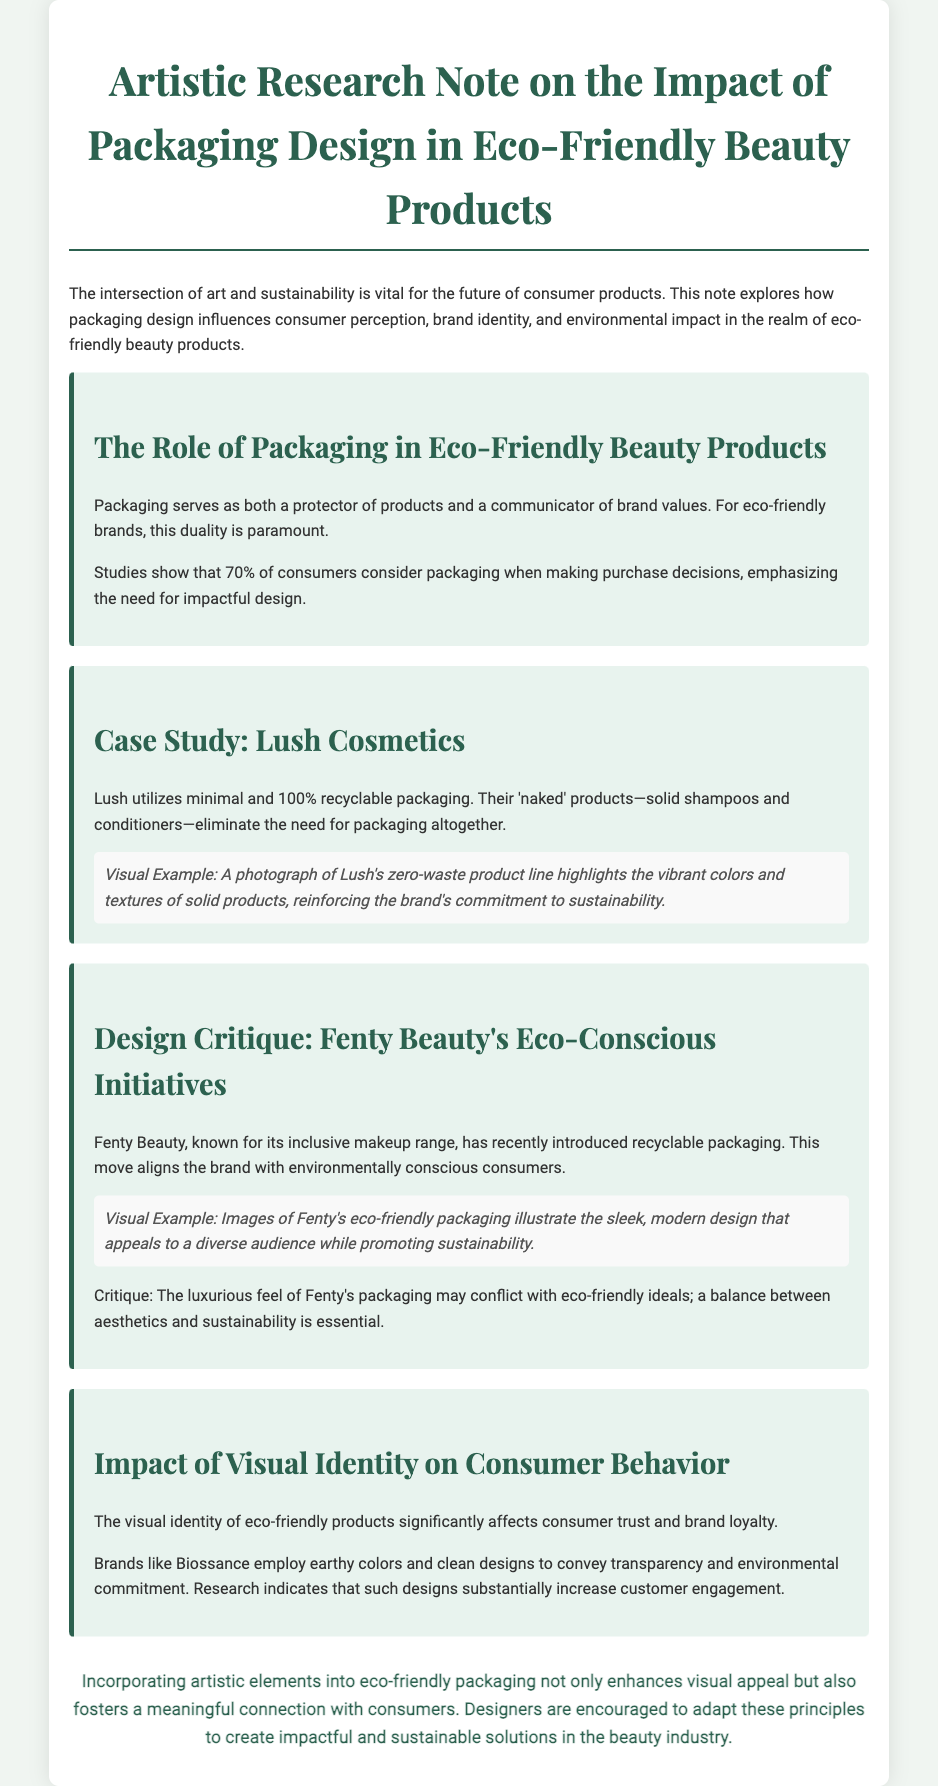what percentage of consumers consider packaging when making purchase decisions? The document states that studies show 70% of consumers consider packaging when making purchase decisions.
Answer: 70% what is one characteristic of Lush's packaging? The note mentions Lush utilizes minimal and 100% recyclable packaging as a key characteristic.
Answer: minimal and 100% recyclable what type of products does Lush offer that eliminate the need for packaging? According to the document, Lush's 'naked' products such as solid shampoos and conditioners eliminate the need for packaging.
Answer: naked products who introduced recyclable packaging in their products? The document states that Fenty Beauty has recently introduced recyclable packaging in their products.
Answer: Fenty Beauty what design elements do brands like Biossance use to convey transparency? The note mentions that Biossance employs earthy colors and clean designs as visual elements to convey transparency.
Answer: earthy colors and clean designs what is a potential conflict in Fenty Beauty's packaging design? The critique points out a conflict between the luxurious feel of Fenty's packaging and eco-friendly ideals.
Answer: luxurious feel vs. eco-friendly ideals what type of research indicates that certain designs increase customer engagement? The document refers to research that indicates that earthy colors and clean designs substantially increase customer engagement.
Answer: research what is the main theme of the artistic research note? The document discusses the impact of packaging design in eco-friendly beauty products, focusing on brand perception and sustainability.
Answer: impact of packaging design on sustainability 